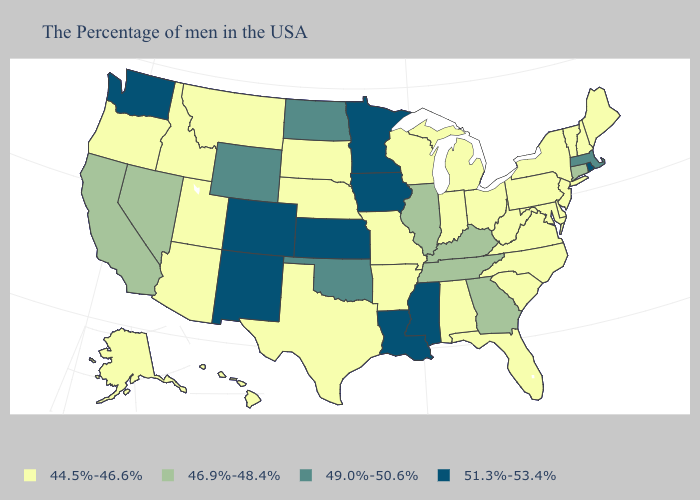How many symbols are there in the legend?
Answer briefly. 4. What is the value of Missouri?
Keep it brief. 44.5%-46.6%. Name the states that have a value in the range 49.0%-50.6%?
Give a very brief answer. Massachusetts, Oklahoma, North Dakota, Wyoming. Does Hawaii have the lowest value in the West?
Keep it brief. Yes. Which states have the lowest value in the MidWest?
Be succinct. Ohio, Michigan, Indiana, Wisconsin, Missouri, Nebraska, South Dakota. Which states have the lowest value in the Northeast?
Be succinct. Maine, New Hampshire, Vermont, New York, New Jersey, Pennsylvania. Name the states that have a value in the range 44.5%-46.6%?
Write a very short answer. Maine, New Hampshire, Vermont, New York, New Jersey, Delaware, Maryland, Pennsylvania, Virginia, North Carolina, South Carolina, West Virginia, Ohio, Florida, Michigan, Indiana, Alabama, Wisconsin, Missouri, Arkansas, Nebraska, Texas, South Dakota, Utah, Montana, Arizona, Idaho, Oregon, Alaska, Hawaii. Name the states that have a value in the range 49.0%-50.6%?
Keep it brief. Massachusetts, Oklahoma, North Dakota, Wyoming. Among the states that border Kentucky , which have the lowest value?
Keep it brief. Virginia, West Virginia, Ohio, Indiana, Missouri. What is the lowest value in the MidWest?
Be succinct. 44.5%-46.6%. Which states have the lowest value in the USA?
Concise answer only. Maine, New Hampshire, Vermont, New York, New Jersey, Delaware, Maryland, Pennsylvania, Virginia, North Carolina, South Carolina, West Virginia, Ohio, Florida, Michigan, Indiana, Alabama, Wisconsin, Missouri, Arkansas, Nebraska, Texas, South Dakota, Utah, Montana, Arizona, Idaho, Oregon, Alaska, Hawaii. Which states have the highest value in the USA?
Concise answer only. Rhode Island, Mississippi, Louisiana, Minnesota, Iowa, Kansas, Colorado, New Mexico, Washington. Name the states that have a value in the range 44.5%-46.6%?
Give a very brief answer. Maine, New Hampshire, Vermont, New York, New Jersey, Delaware, Maryland, Pennsylvania, Virginia, North Carolina, South Carolina, West Virginia, Ohio, Florida, Michigan, Indiana, Alabama, Wisconsin, Missouri, Arkansas, Nebraska, Texas, South Dakota, Utah, Montana, Arizona, Idaho, Oregon, Alaska, Hawaii. What is the value of North Dakota?
Give a very brief answer. 49.0%-50.6%. 